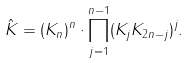<formula> <loc_0><loc_0><loc_500><loc_500>\hat { K } = ( K _ { n } ) ^ { n } \cdot \prod _ { j = 1 } ^ { n - 1 } ( K _ { j } K _ { 2 n - j } ) ^ { j } .</formula> 